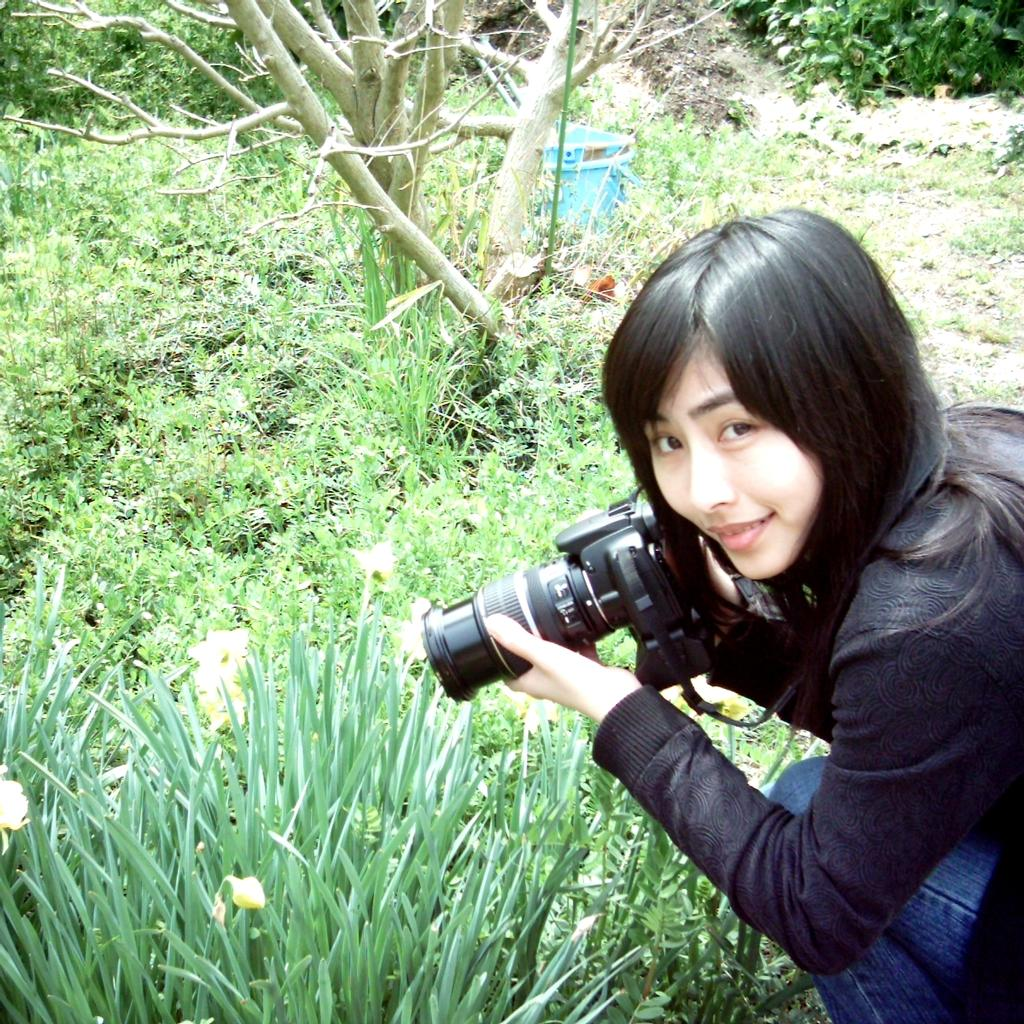Who is present in the image? There is a woman in the image. What is the woman holding in her hand? The woman is holding a camera in her hand. What type of plant can be seen in the image? There is a tree in the image. What type of ground cover is visible in the image? There is grass visible in the image. What type of plastic material is being used to play basketball in the image? There is no basketball or plastic material present in the image. 